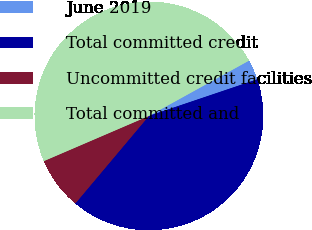Convert chart. <chart><loc_0><loc_0><loc_500><loc_500><pie_chart><fcel>June 2019<fcel>Total committed credit<fcel>Uncommitted credit facilities<fcel>Total committed and<nl><fcel>2.85%<fcel>41.31%<fcel>7.41%<fcel>48.43%<nl></chart> 